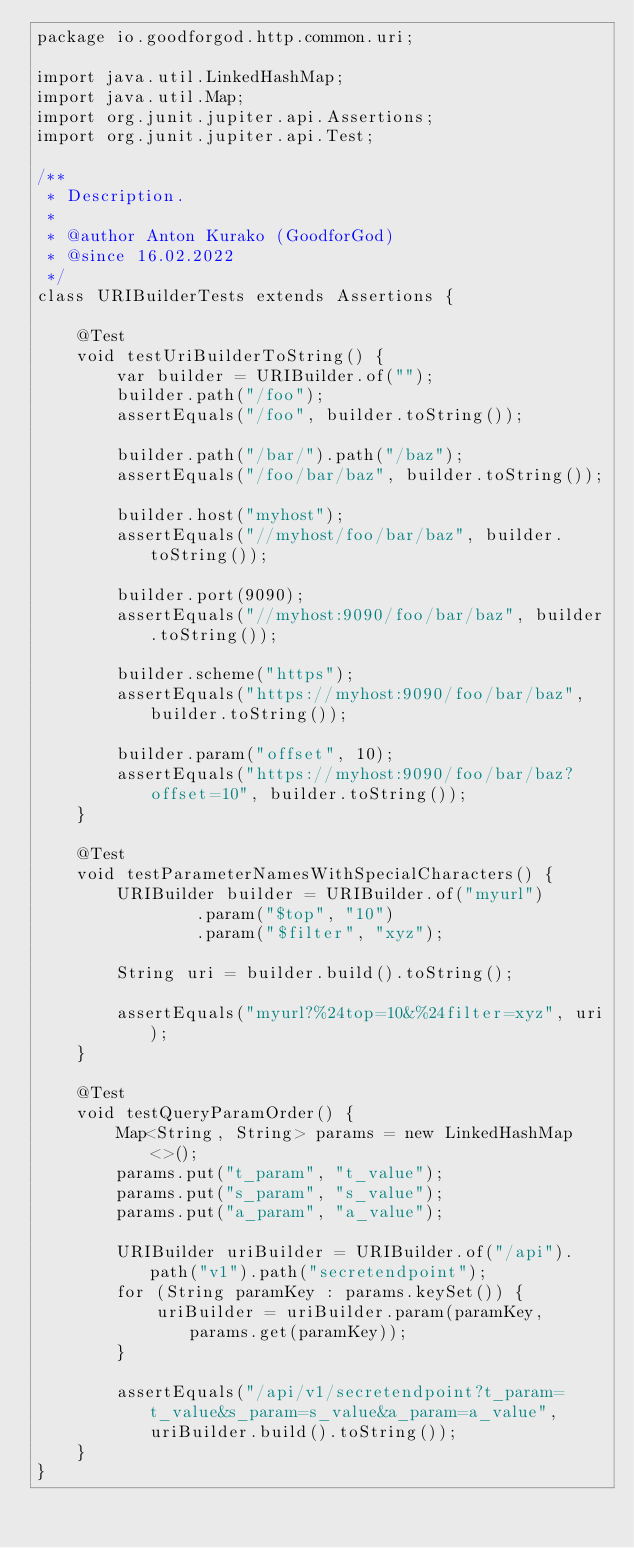<code> <loc_0><loc_0><loc_500><loc_500><_Java_>package io.goodforgod.http.common.uri;

import java.util.LinkedHashMap;
import java.util.Map;
import org.junit.jupiter.api.Assertions;
import org.junit.jupiter.api.Test;

/**
 * Description.
 *
 * @author Anton Kurako (GoodforGod)
 * @since 16.02.2022
 */
class URIBuilderTests extends Assertions {

    @Test
    void testUriBuilderToString() {
        var builder = URIBuilder.of("");
        builder.path("/foo");
        assertEquals("/foo", builder.toString());

        builder.path("/bar/").path("/baz");
        assertEquals("/foo/bar/baz", builder.toString());

        builder.host("myhost");
        assertEquals("//myhost/foo/bar/baz", builder.toString());

        builder.port(9090);
        assertEquals("//myhost:9090/foo/bar/baz", builder.toString());

        builder.scheme("https");
        assertEquals("https://myhost:9090/foo/bar/baz", builder.toString());

        builder.param("offset", 10);
        assertEquals("https://myhost:9090/foo/bar/baz?offset=10", builder.toString());
    }

    @Test
    void testParameterNamesWithSpecialCharacters() {
        URIBuilder builder = URIBuilder.of("myurl")
                .param("$top", "10")
                .param("$filter", "xyz");

        String uri = builder.build().toString();

        assertEquals("myurl?%24top=10&%24filter=xyz", uri);
    }

    @Test
    void testQueryParamOrder() {
        Map<String, String> params = new LinkedHashMap<>();
        params.put("t_param", "t_value");
        params.put("s_param", "s_value");
        params.put("a_param", "a_value");

        URIBuilder uriBuilder = URIBuilder.of("/api").path("v1").path("secretendpoint");
        for (String paramKey : params.keySet()) {
            uriBuilder = uriBuilder.param(paramKey, params.get(paramKey));
        }

        assertEquals("/api/v1/secretendpoint?t_param=t_value&s_param=s_value&a_param=a_value", uriBuilder.build().toString());
    }
}
</code> 